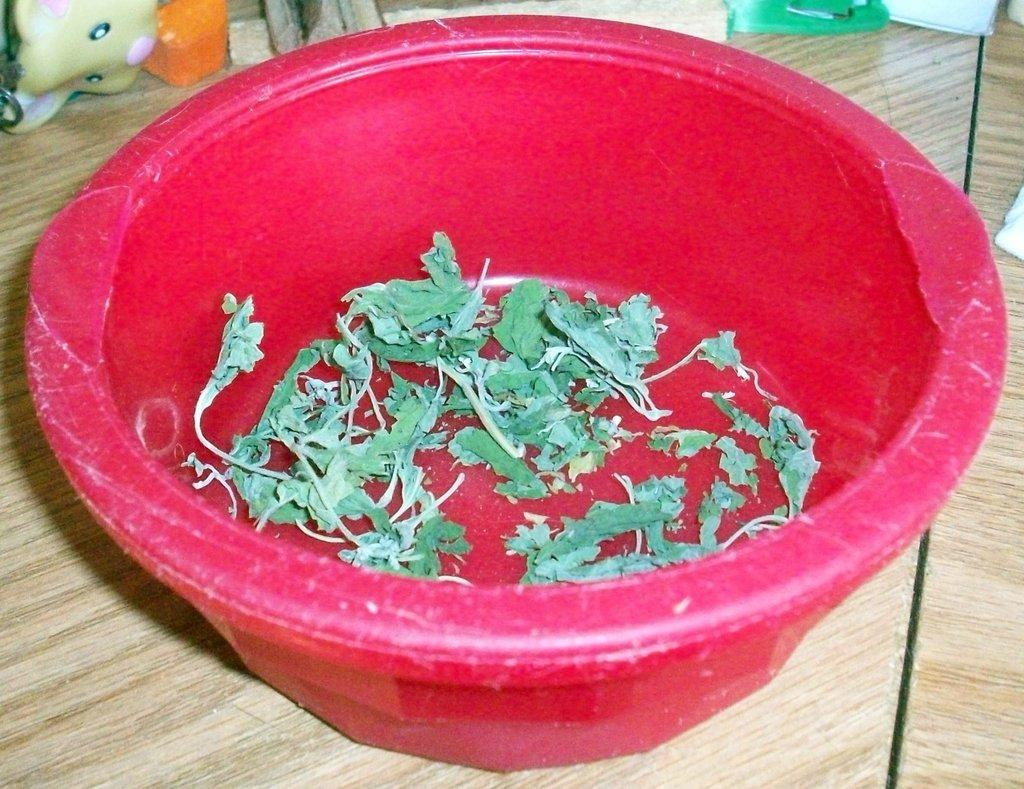What is in the bowl that is visible in the image? There are herbs in a bowl in the image. What other object is near the bowl in the image? There is a doll beside the bowl in the image. Where are the bowl and doll located in the image? The bowl and doll are placed on a table. Can you tell me how many wrens are sitting on the doll's head in the image? There are no wrens present in the image; it features a bowl of herbs and a doll on a table. 